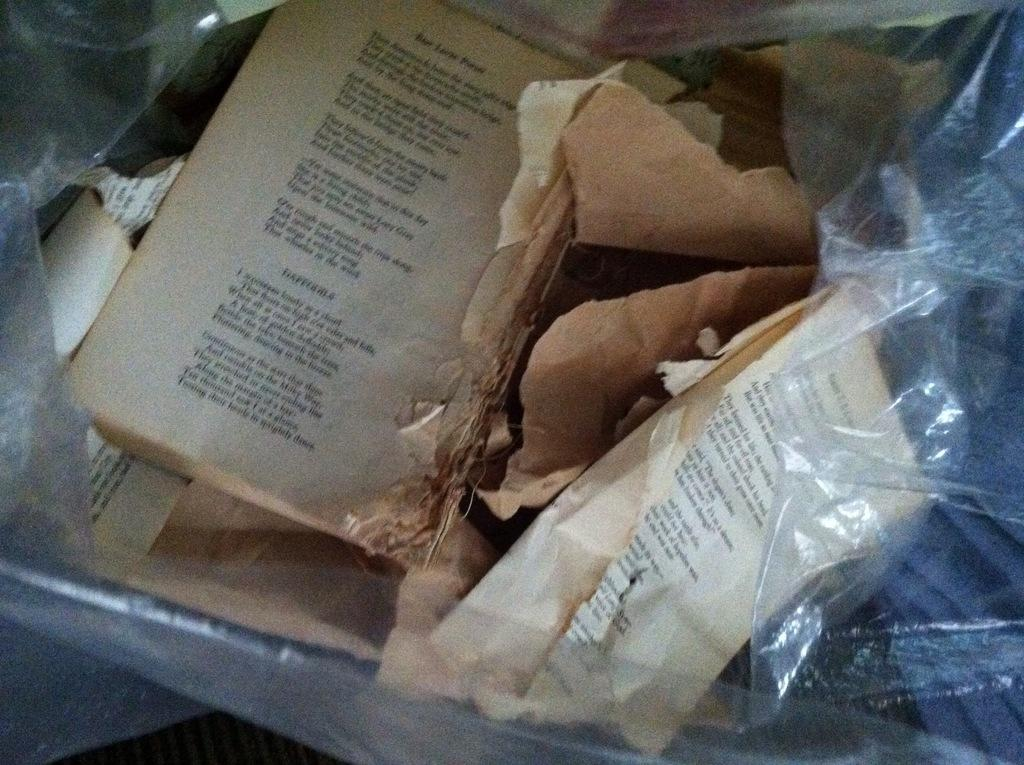What is depicted in the image? There are pages of a book in the image. How are the pages organized? The pages are present in a cover. What type of operation is being performed on the mother in the image? There is no operation or mother present in the image; it only features pages of a book in a cover. How many branches can be seen growing from the tree in the image? There is no tree or branches present in the image; it only features pages of a book in a cover. 